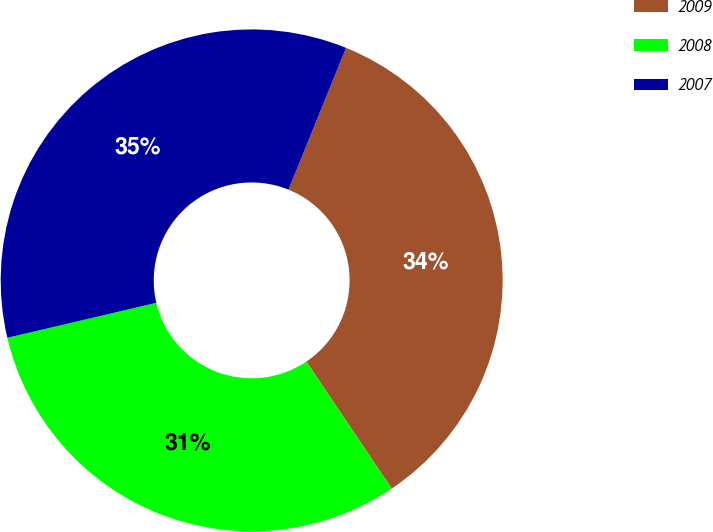Convert chart to OTSL. <chart><loc_0><loc_0><loc_500><loc_500><pie_chart><fcel>2009<fcel>2008<fcel>2007<nl><fcel>34.44%<fcel>30.75%<fcel>34.81%<nl></chart> 